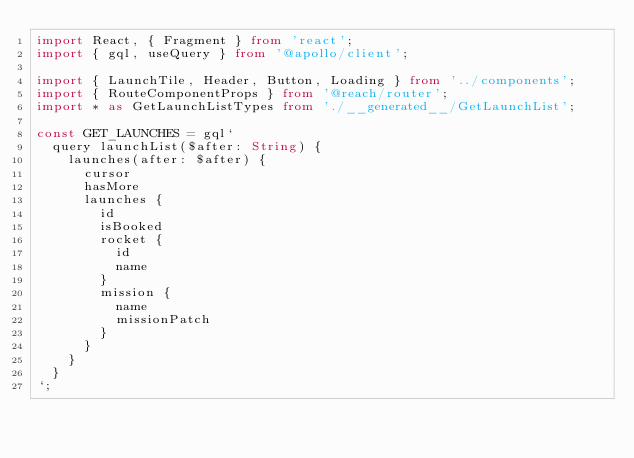Convert code to text. <code><loc_0><loc_0><loc_500><loc_500><_TypeScript_>import React, { Fragment } from 'react';
import { gql, useQuery } from '@apollo/client';

import { LaunchTile, Header, Button, Loading } from '../components';
import { RouteComponentProps } from '@reach/router';
import * as GetLaunchListTypes from './__generated__/GetLaunchList';

const GET_LAUNCHES = gql`
  query launchList($after: String) {
    launches(after: $after) {
      cursor
      hasMore
      launches {
        id
        isBooked
        rocket {
          id
          name
        }
        mission {
          name
          missionPatch
        }
      }
    }
  }
`;</code> 